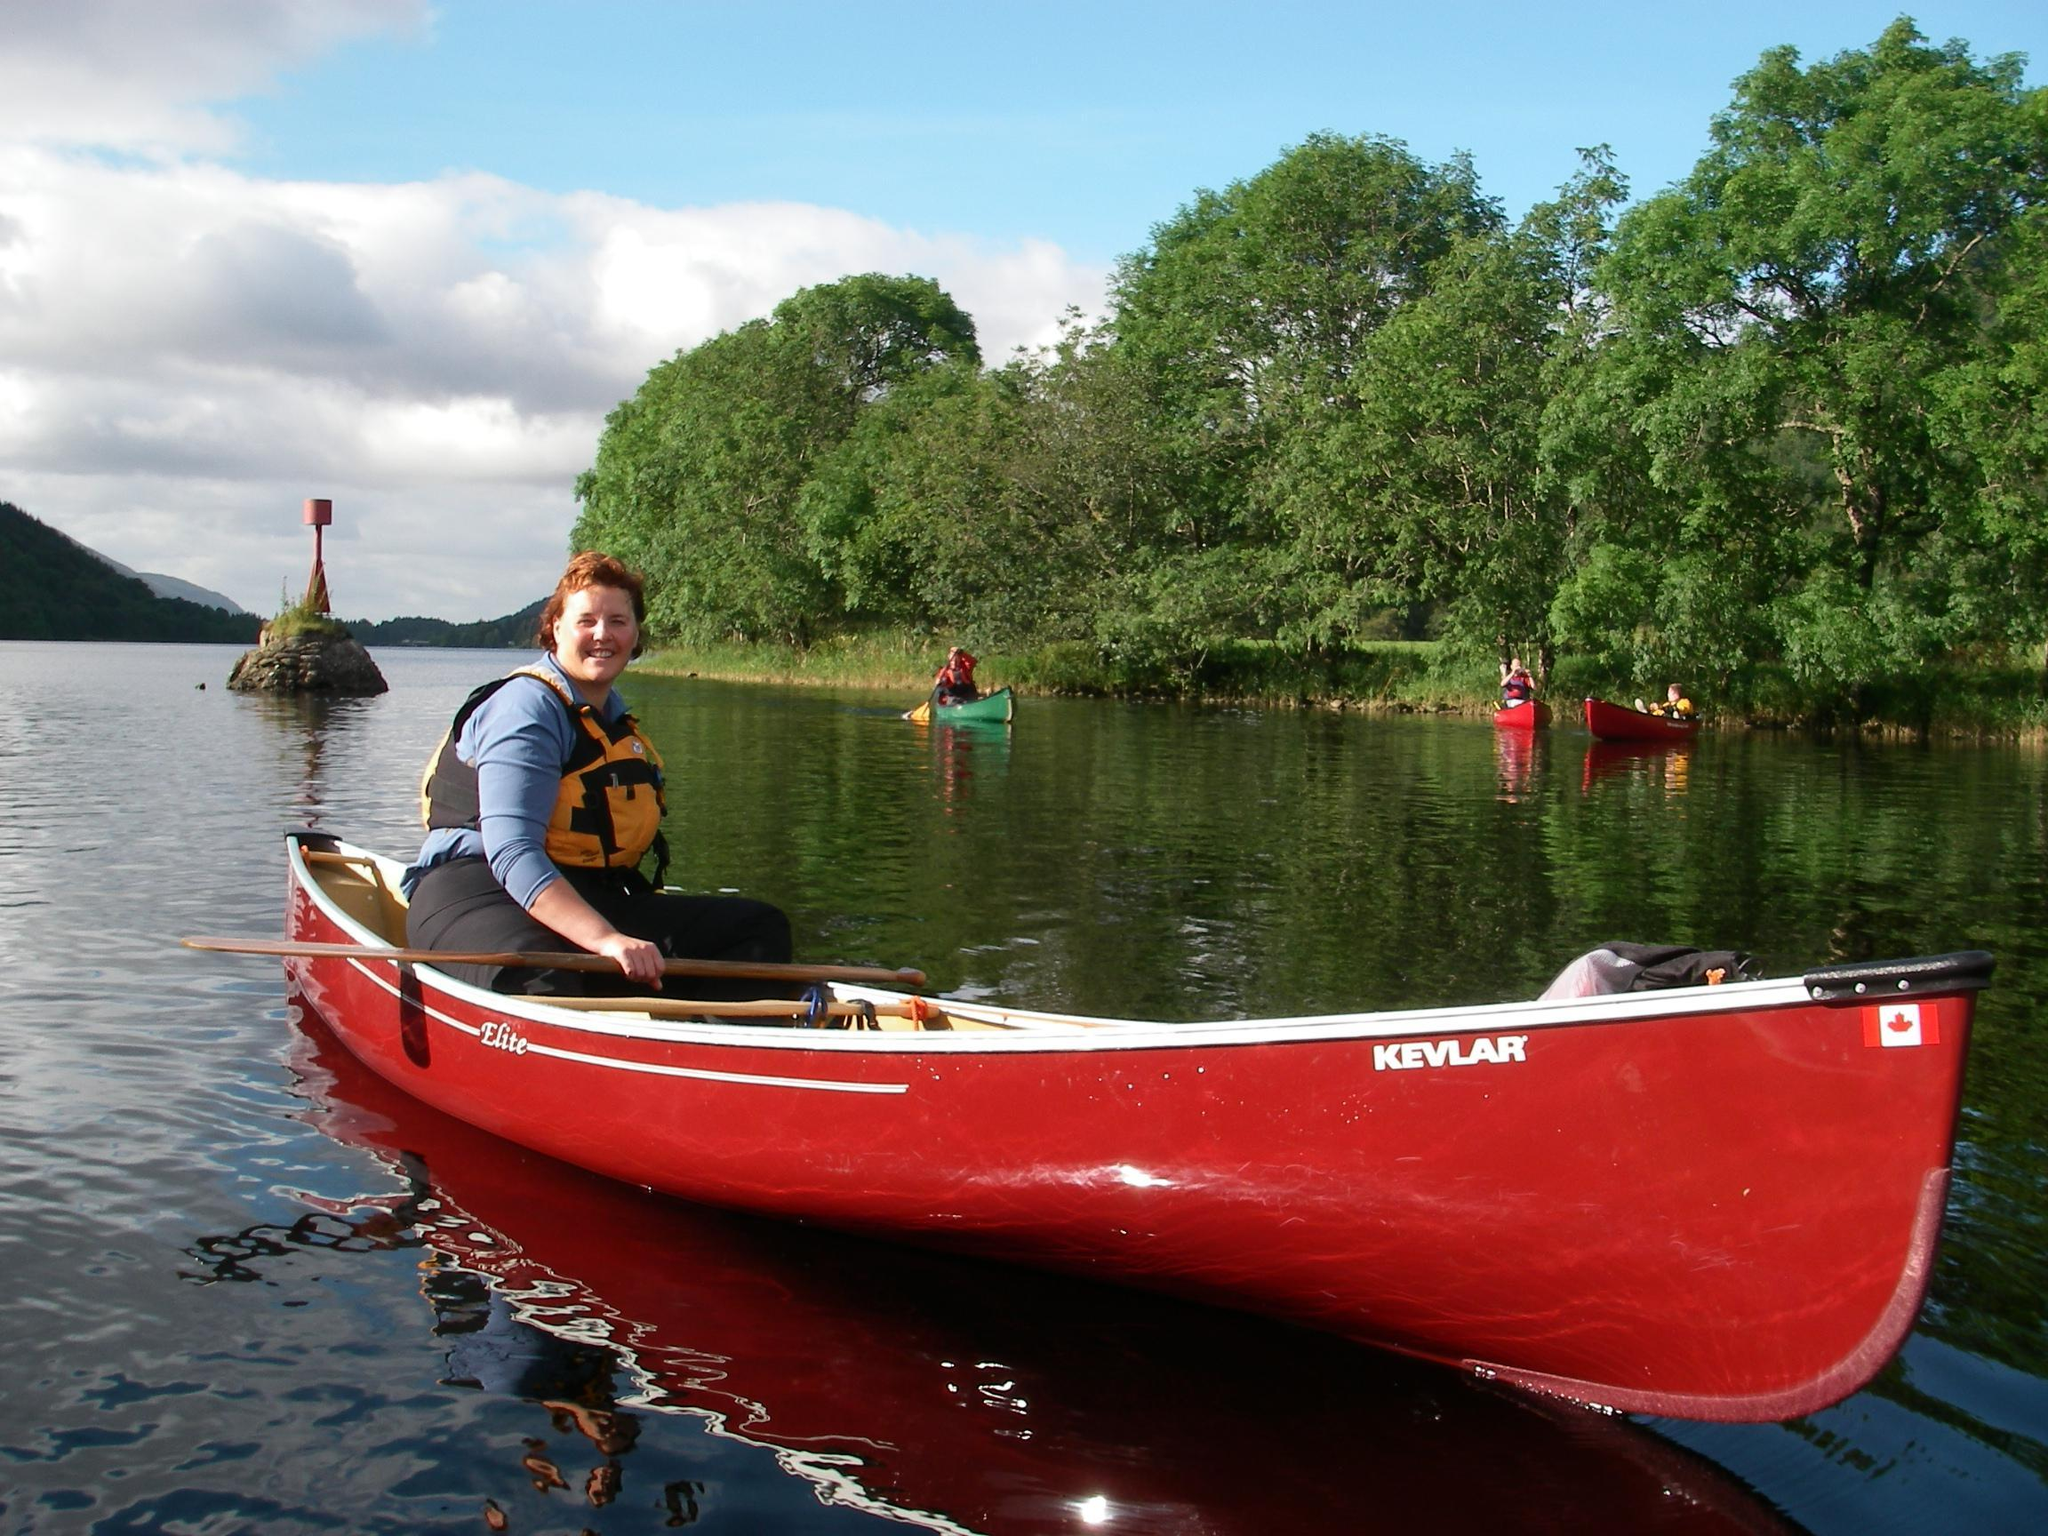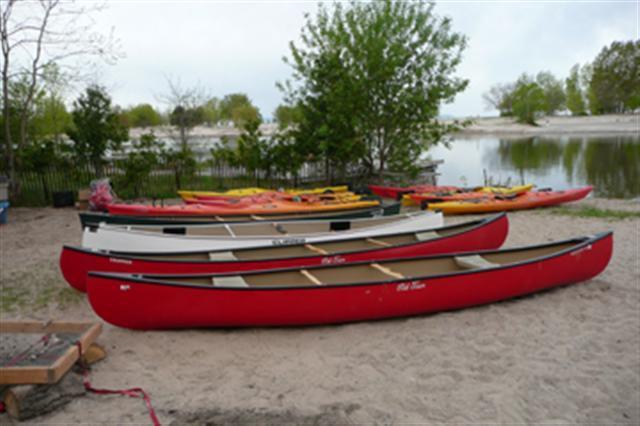The first image is the image on the left, the second image is the image on the right. Considering the images on both sides, is "The combined images include several red and yellow boats pulled up on shore." valid? Answer yes or no. Yes. The first image is the image on the left, the second image is the image on the right. Given the left and right images, does the statement "In at least one image there a at least two red boats on the shore." hold true? Answer yes or no. Yes. 